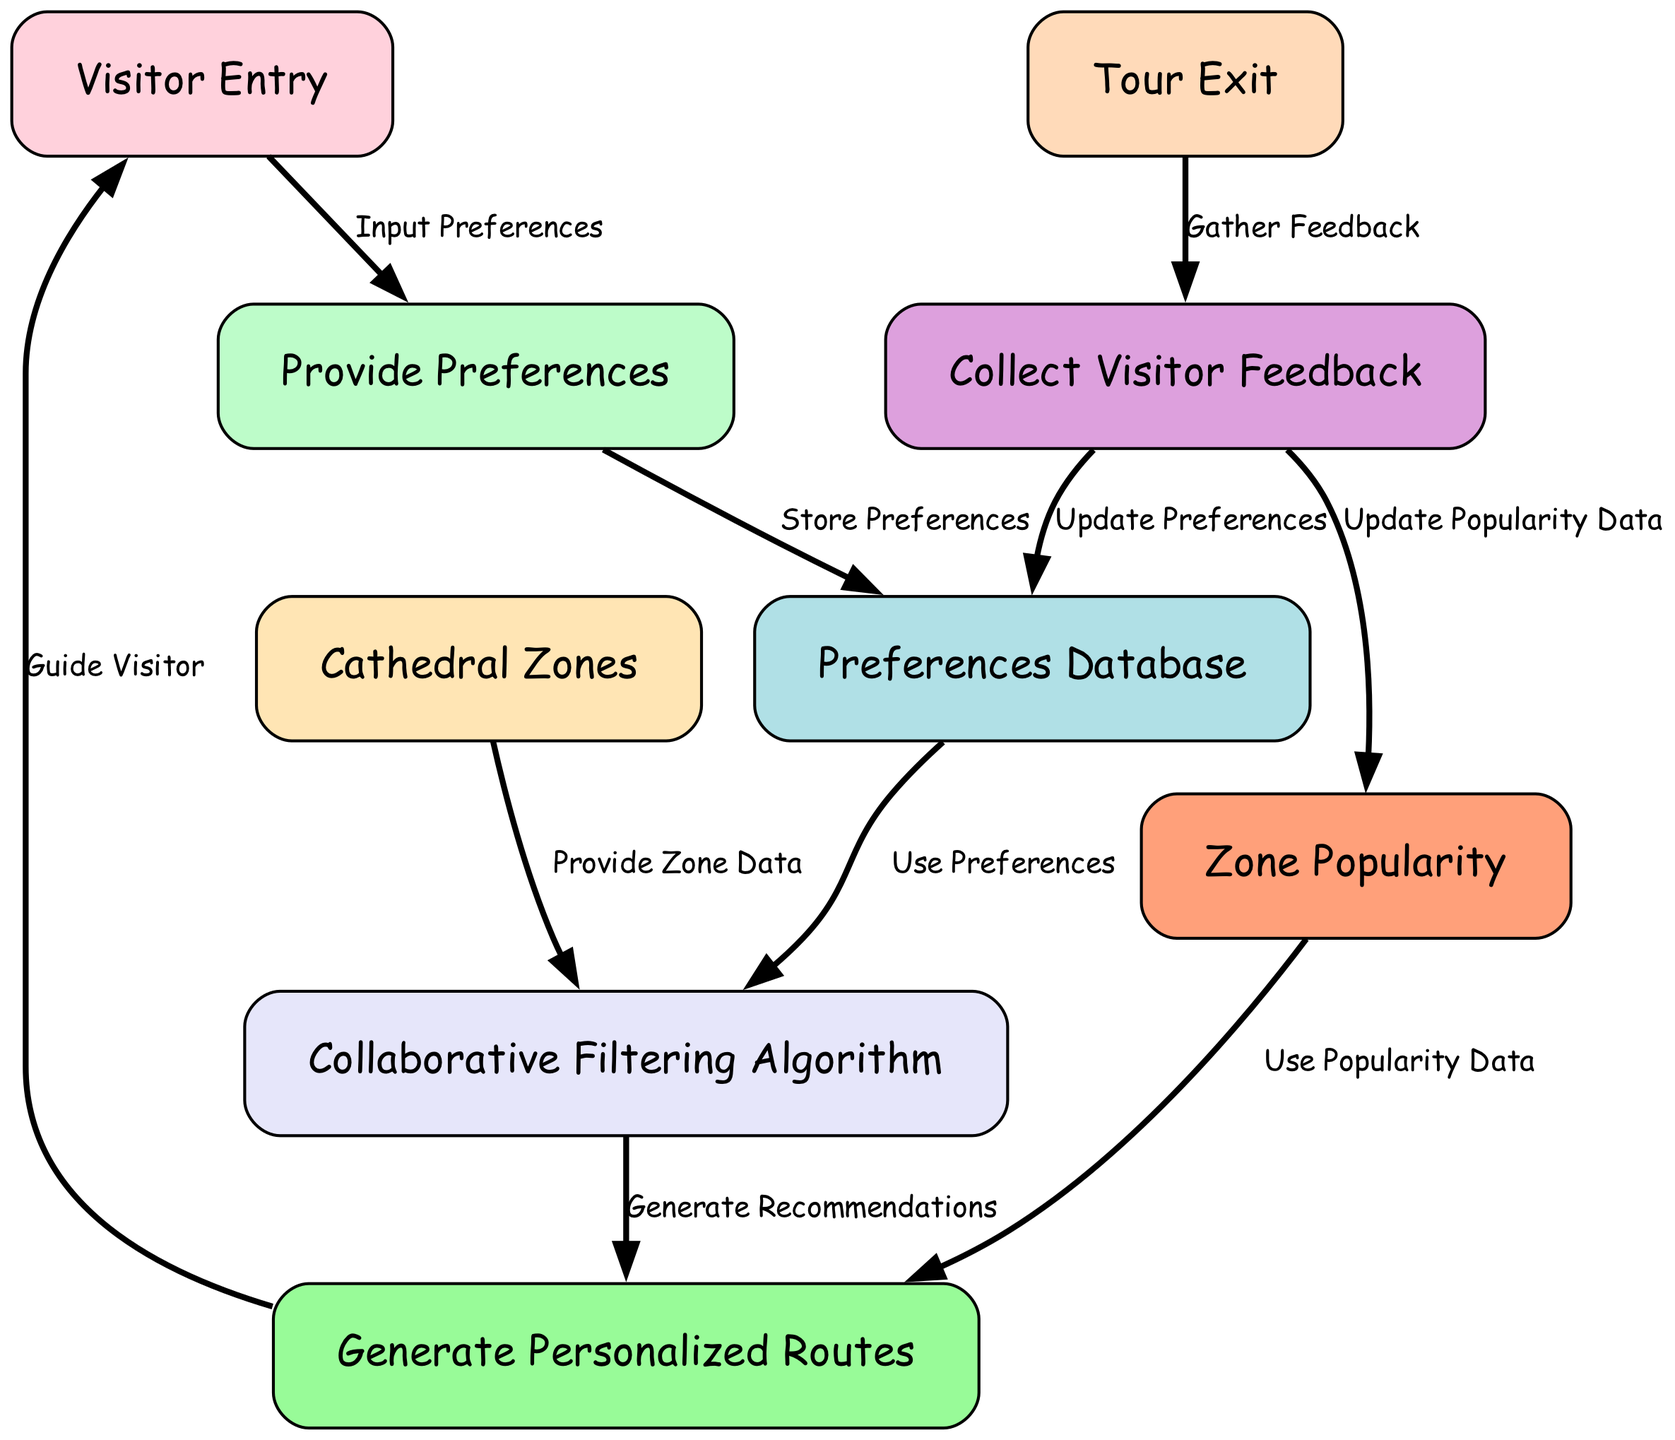What is the first node in the diagram? The first node, where visitors begin their journey, is labeled "Visitor Entry."
Answer: Visitor Entry How many nodes are in the diagram? By counting each of the distinct nodes listed, there are a total of 9 nodes present in the diagram.
Answer: 9 What does the "preferencesInput" node do? The "preferencesInput" node is responsible for gathering visitor preferences, which then flow into the preferences database.
Answer: Provide Preferences What connects "preferencesDatabase" to "collaborativeFiltering"? The edge labeled "Use Preferences" connects the "preferencesDatabase" node to the "collaborativeFiltering" node, indicating the flow of data.
Answer: Use Preferences Which node is at the end of the tour process? The "tourExit" node represents the conclusion of the visitor's tour experience, marking their exit from the cathedral.
Answer: Tour Exit How does visitor feedback influence the diagram? Visitor feedback collected through the "feedbackCollection" node leads to updates in both the preferences database and the zone popularity data, improving future recommendations.
Answer: Updates Preferences & Popularity Data Which nodes interact with the "personalizedRoutes" node? The "personalizedRoutes" node interacts with "collaborativeFiltering" for recommendations and is informed by "zonePopularity" for optimizing routes for visitors.
Answer: collaborativeFiltering & zonePopularity What does "zonePopularity" provide to the recommendations? The "zonePopularity" node supplies the personalized route generation process with popularity data about different cathedral zones, helping to tailor recommendations.
Answer: Use Popularity Data Where does the visitor feedback go after it is collected? After collecting feedback, the information flows into two areas: it updates the "preferencesDatabase" and updates the "zonePopularity" data.
Answer: preferencesDatabase & zonePopularity 